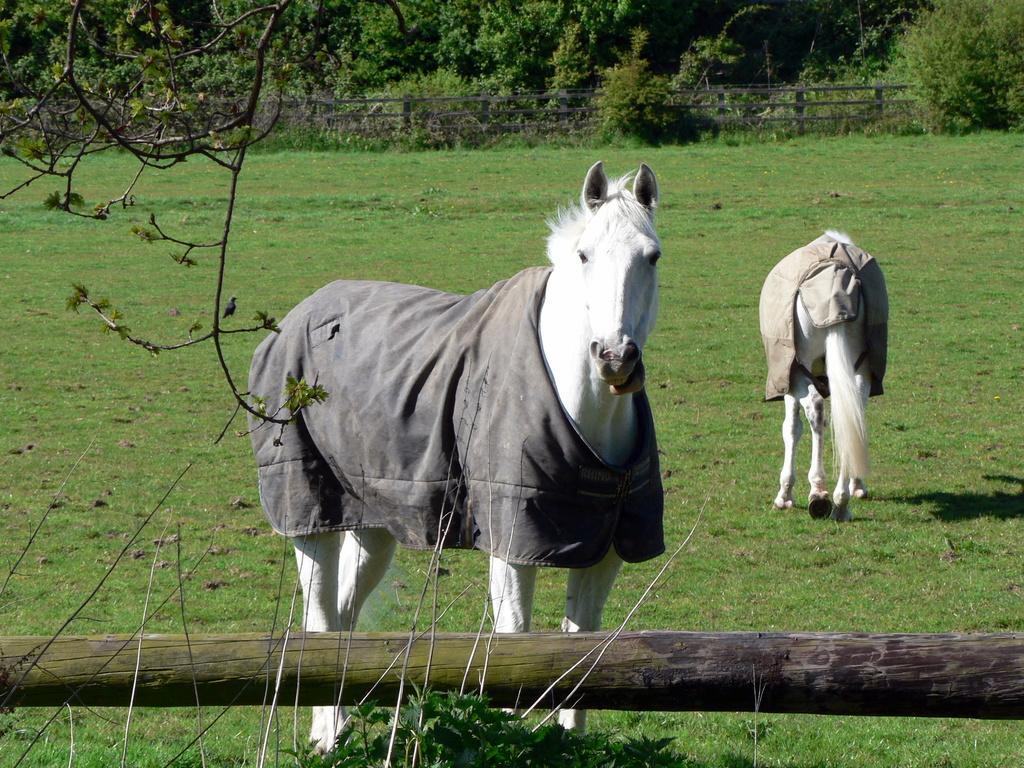Describe this image in one or two sentences. This picture shows couple of horses with clothes on their body and we see trees and a fence and grass on the ground both the horses are white in color. 